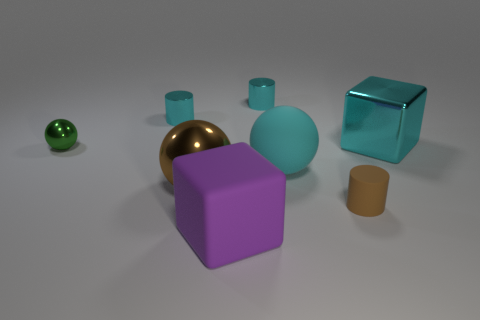Is the number of shiny objects less than the number of small gray matte cylinders?
Offer a terse response. No. What material is the green object that is the same size as the brown cylinder?
Give a very brief answer. Metal. Are there more matte cylinders than large red balls?
Offer a very short reply. Yes. How many other objects are there of the same color as the large rubber ball?
Provide a succinct answer. 3. How many objects are on the left side of the brown matte object and to the right of the small green sphere?
Provide a short and direct response. 5. Is there anything else that has the same size as the brown matte cylinder?
Your answer should be compact. Yes. Are there more metallic balls that are left of the brown metallic sphere than tiny things on the left side of the big purple thing?
Ensure brevity in your answer.  No. There is a small green sphere that is to the left of the large matte sphere; what is it made of?
Provide a short and direct response. Metal. Does the cyan matte thing have the same shape as the metallic object on the right side of the small brown cylinder?
Give a very brief answer. No. How many purple cubes are on the left side of the block that is left of the shiny thing that is to the right of the tiny brown matte cylinder?
Your response must be concise. 0. 